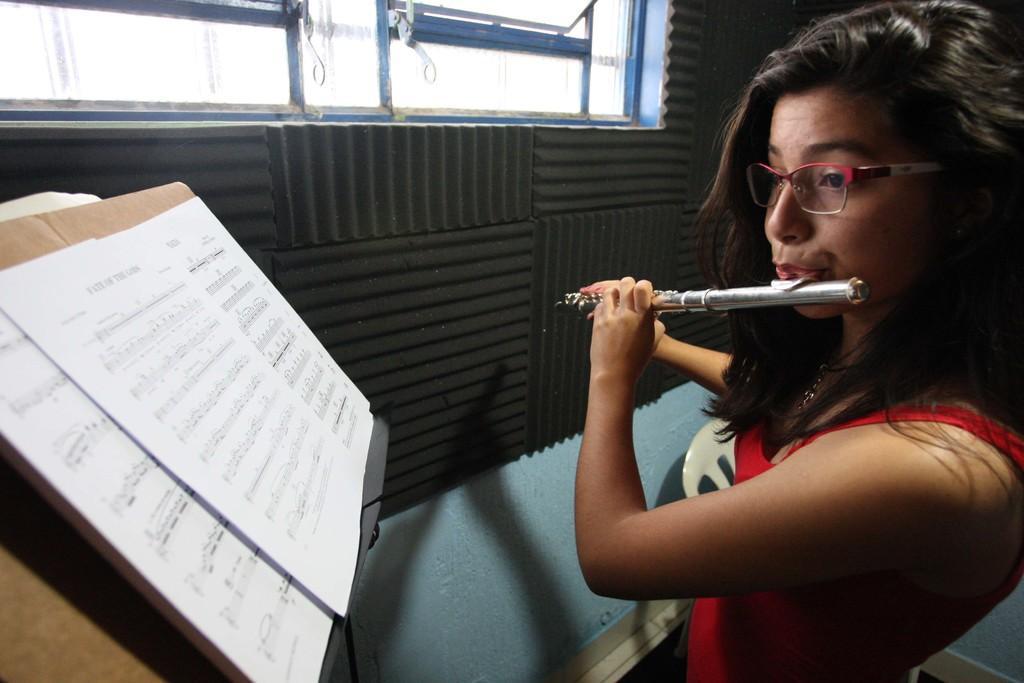In one or two sentences, can you explain what this image depicts? In this image I can see a person playing the flute. In front of her there are some papers. To the right of her there is a window to the wall. 